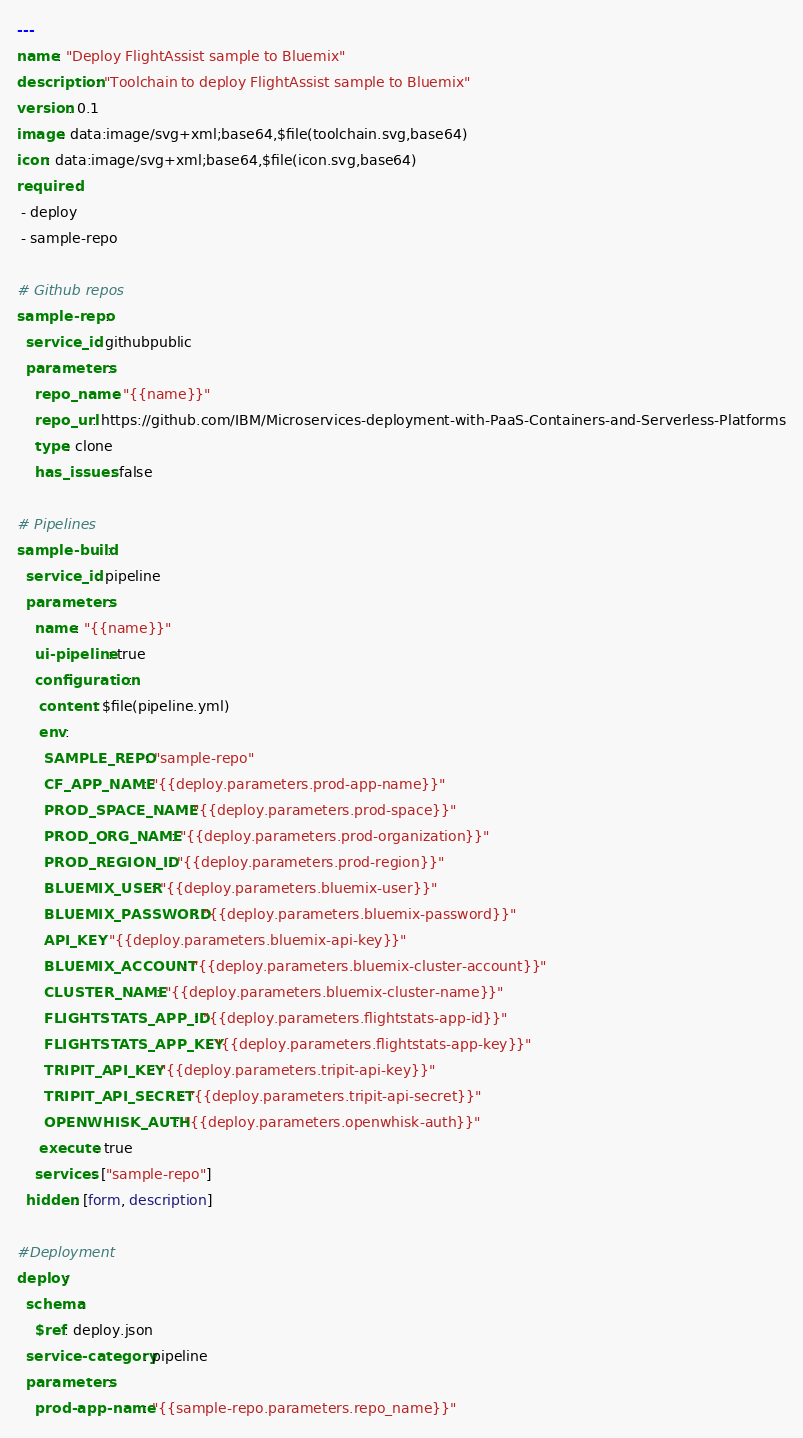<code> <loc_0><loc_0><loc_500><loc_500><_YAML_>---
name: "Deploy FlightAssist sample to Bluemix"
description: "Toolchain to deploy FlightAssist sample to Bluemix"
version: 0.1
image: data:image/svg+xml;base64,$file(toolchain.svg,base64)
icon: data:image/svg+xml;base64,$file(icon.svg,base64)
required:
 - deploy
 - sample-repo

# Github repos
sample-repo:
  service_id: githubpublic
  parameters:
    repo_name: "{{name}}"
    repo_url: https://github.com/IBM/Microservices-deployment-with-PaaS-Containers-and-Serverless-Platforms
    type: clone
    has_issues: false

# Pipelines
sample-build:
  service_id: pipeline
  parameters:
    name: "{{name}}"
    ui-pipeline: true
    configuration:
     content: $file(pipeline.yml)
     env:
      SAMPLE_REPO: "sample-repo"
      CF_APP_NAME: "{{deploy.parameters.prod-app-name}}"
      PROD_SPACE_NAME: "{{deploy.parameters.prod-space}}"
      PROD_ORG_NAME: "{{deploy.parameters.prod-organization}}"
      PROD_REGION_ID: "{{deploy.parameters.prod-region}}"
      BLUEMIX_USER: "{{deploy.parameters.bluemix-user}}"
      BLUEMIX_PASSWORD: "{{deploy.parameters.bluemix-password}}"
      API_KEY: "{{deploy.parameters.bluemix-api-key}}"
      BLUEMIX_ACCOUNT: "{{deploy.parameters.bluemix-cluster-account}}"
      CLUSTER_NAME: "{{deploy.parameters.bluemix-cluster-name}}"
      FLIGHTSTATS_APP_ID: "{{deploy.parameters.flightstats-app-id}}"
      FLIGHTSTATS_APP_KEY: "{{deploy.parameters.flightstats-app-key}}"
      TRIPIT_API_KEY: "{{deploy.parameters.tripit-api-key}}"
      TRIPIT_API_SECRET: "{{deploy.parameters.tripit-api-secret}}"
      OPENWHISK_AUTH: "{{deploy.parameters.openwhisk-auth}}"
     execute: true
    services: ["sample-repo"]
  hidden: [form, description]

#Deployment
deploy:
  schema:
    $ref: deploy.json
  service-category: pipeline
  parameters:
    prod-app-name: "{{sample-repo.parameters.repo_name}}"
</code> 